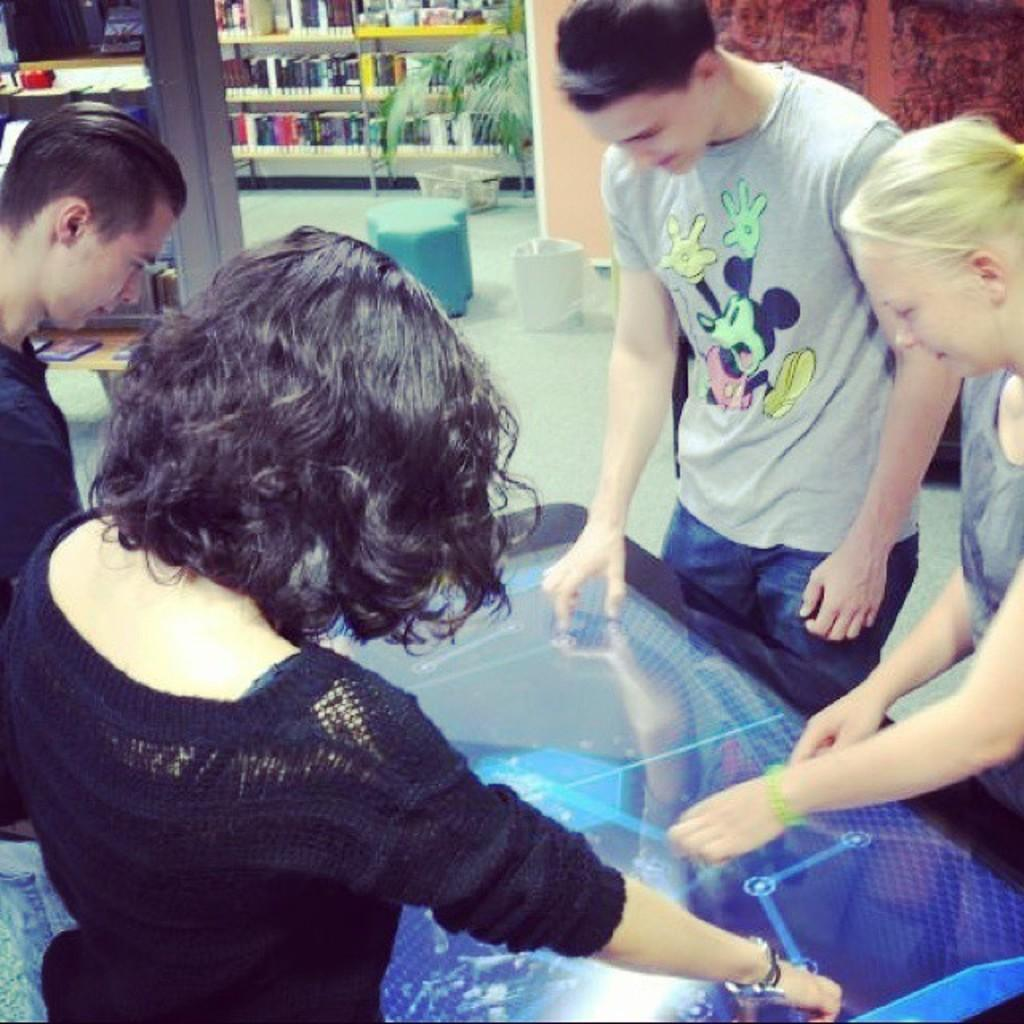How many people are present in the image? There are four people standing around the screen. What can be seen in the background of the image? There is a book rack, a plant pot, a basket, a stool, and another rack in the background. What might the people be doing in the image? The people might be watching something on the screen together. Can you see any ocean, robin, or yak in the image? No, there is no ocean, robin, or yak present in the image. 